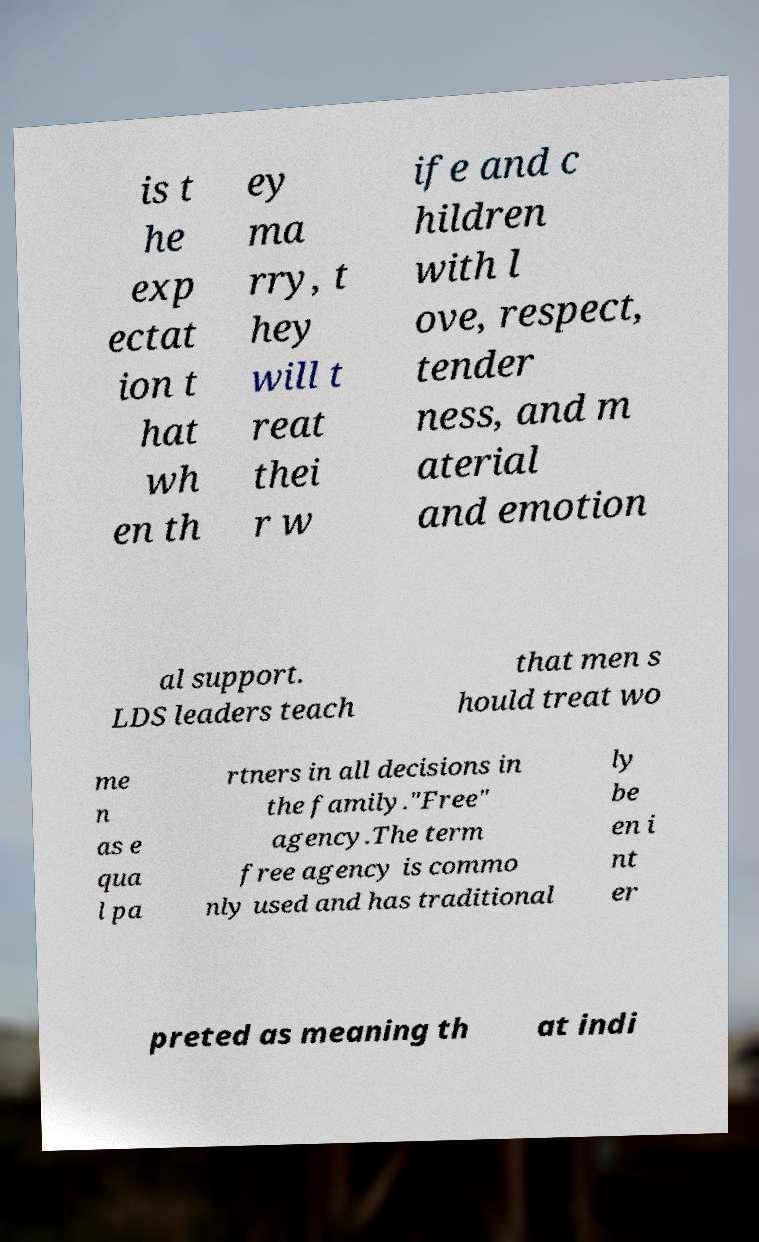There's text embedded in this image that I need extracted. Can you transcribe it verbatim? is t he exp ectat ion t hat wh en th ey ma rry, t hey will t reat thei r w ife and c hildren with l ove, respect, tender ness, and m aterial and emotion al support. LDS leaders teach that men s hould treat wo me n as e qua l pa rtners in all decisions in the family."Free" agency.The term free agency is commo nly used and has traditional ly be en i nt er preted as meaning th at indi 